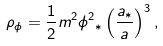<formula> <loc_0><loc_0><loc_500><loc_500>\rho _ { \phi } = \frac { 1 } { 2 } m ^ { 2 } \phi { ^ { 2 } } _ { * } \left ( \frac { a _ { * } } { a } \right ) ^ { 3 } ,</formula> 